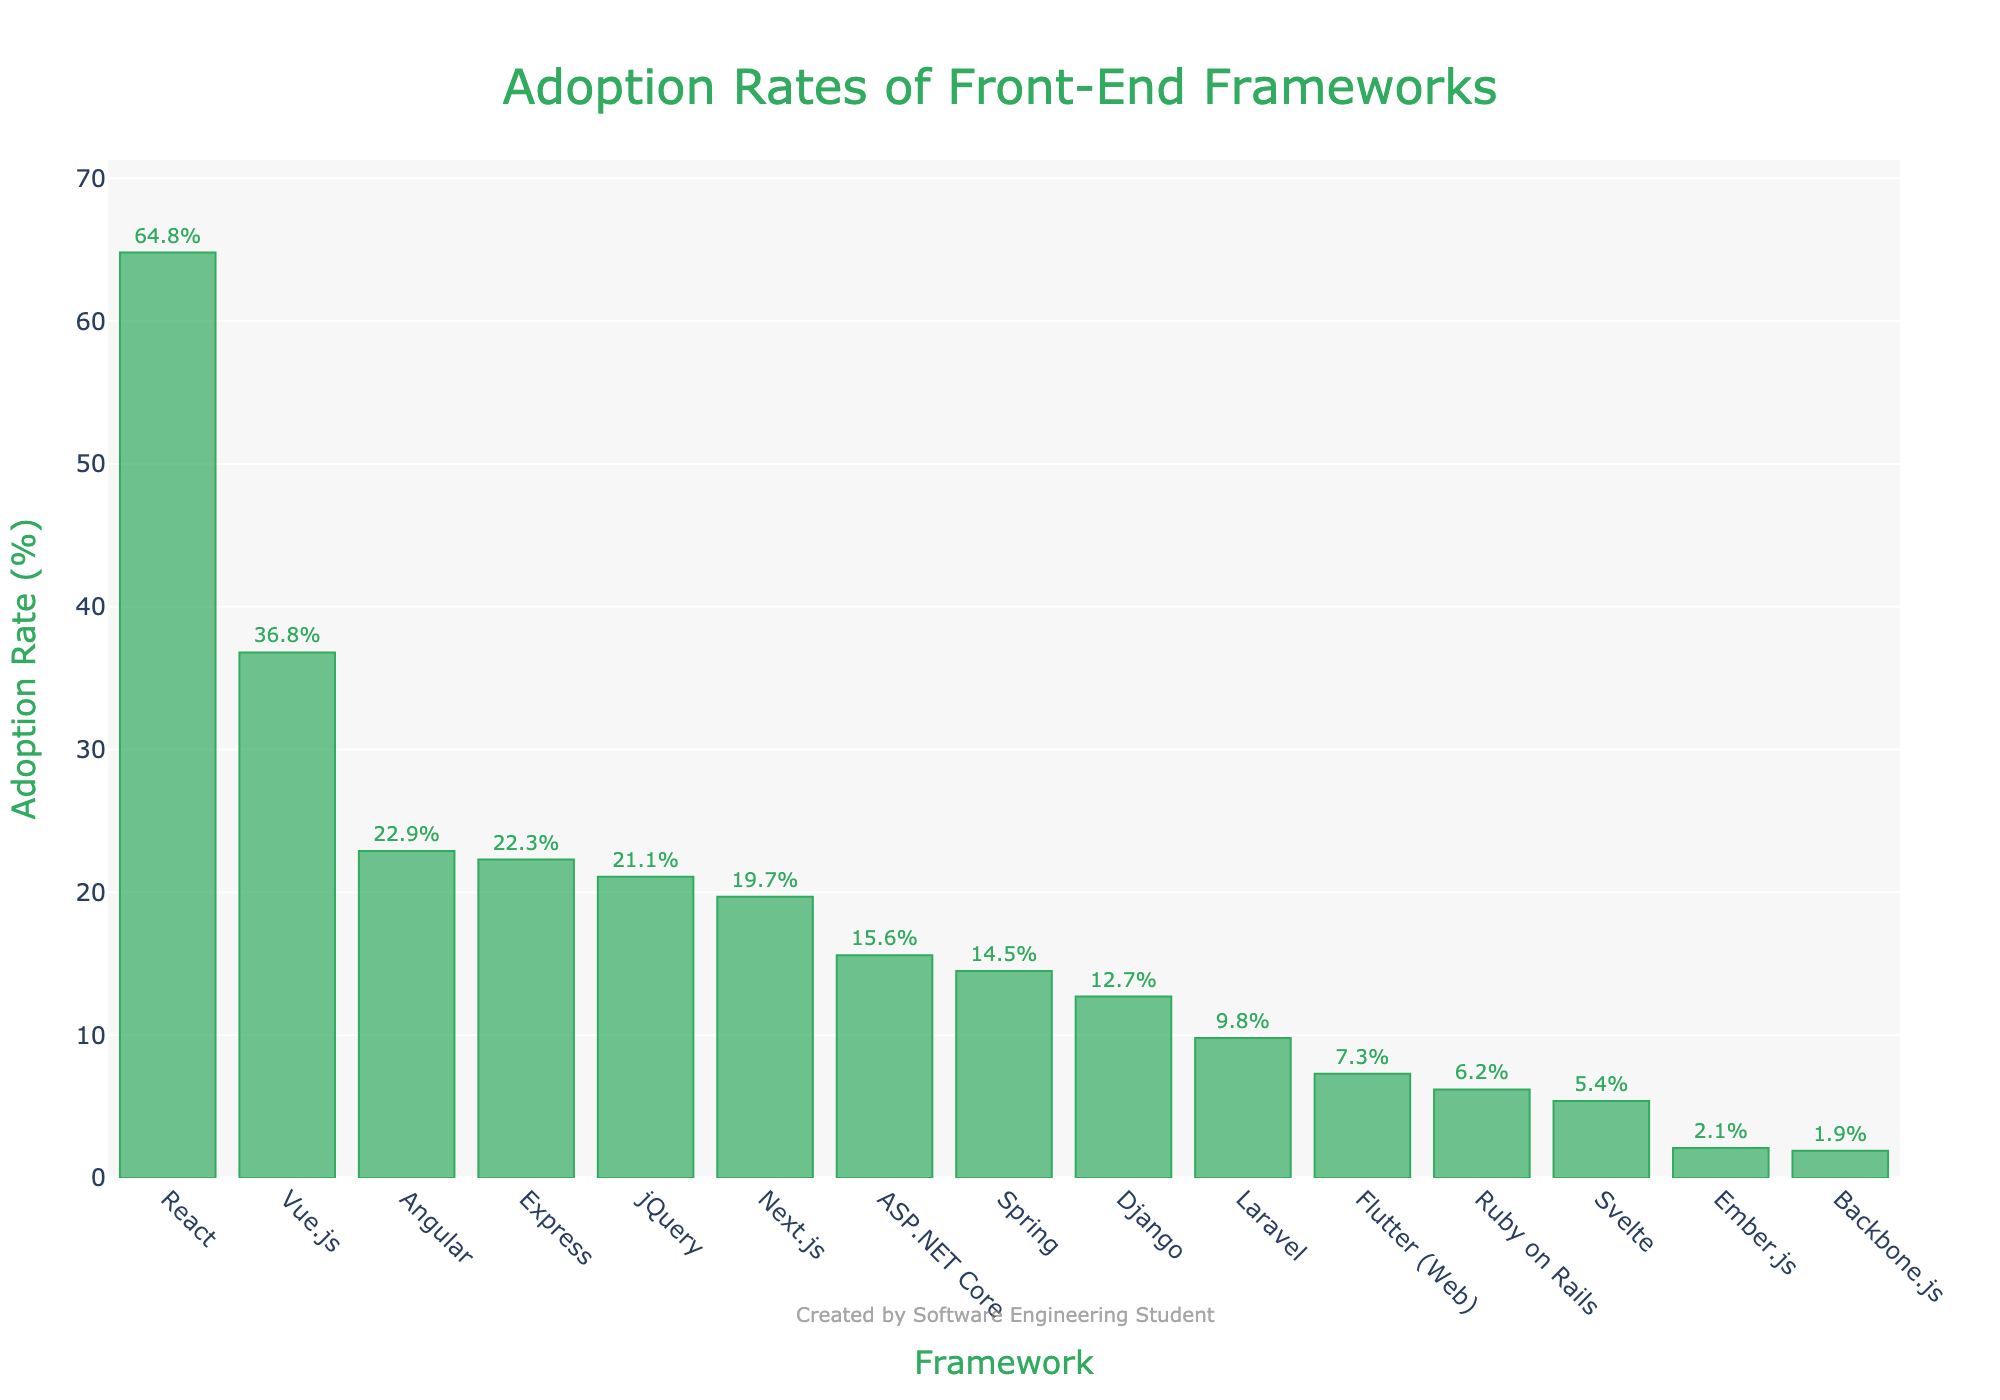Which framework has the highest adoption rate? By examining the heights of the bars, the tallest bar corresponds to React, which has the highest adoption rate.
Answer: React Which framework has the lowest adoption rate? By looking at the shortest bar, Backbone.js has the lowest adoption rate.
Answer: Backbone.js How many frameworks have an adoption rate higher than 20%? From the figure, React, Angular, Vue.js, jQuery, and Express have bars taller than 20%. This totals to five frameworks.
Answer: 5 What is the total adoption rate of Vue.js and Next.js combined? The adoption rate of Vue.js is 36.8% and that of Next.js is 19.7%. Adding these two gives 36.8 + 19.7 = 56.5%.
Answer: 56.5% Which framework has a higher adoption rate, Svelte or Django, and by how much? Svelte has an adoption rate of 5.4%, whereas Django has 12.7%. The difference is 12.7 - 5.4 = 7.3%.
Answer: Django by 7.3% Compare the adoption rates of ASP.NET Core and Spring. Which is higher? ASP.NET Core has an adoption rate of 15.6%, while Spring has 14.5%. Therefore, ASP.NET Core has a slightly higher adoption rate.
Answer: ASP.NET Core What is the average adoption rate of the frameworks listed in the figure? Sum all adoption rates: 64.8 + 22.9 + 36.8 + 5.4 + 19.7 + 21.1 + 22.3 + 15.6 + 6.2 + 9.8 + 14.5 + 12.7 + 7.3 + 2.1 + 1.9 = 263.2. Divide by the number of frameworks (15): 263.2 / 15 = 17.55%.
Answer: 17.55% Is the adoption rate of React more than double that of Angular? React's adoption rate is 64.8%, and Angular's is 22.9%. Doubling Angular’s rate gives 22.9 * 2 = 45.8%. Since 64.8% is more than 45.8%, React's adoption rate is indeed more than double.
Answer: Yes Which has a higher adoption rate, Express or jQuery? Express has an adoption rate of 22.3%, while jQuery has 21.1%. Therefore, Express has a higher adoption rate.
Answer: Express 